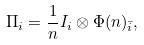<formula> <loc_0><loc_0><loc_500><loc_500>\Pi _ { i } = \frac { 1 } { n } I _ { i } \otimes \Phi ( n ) _ { \bar { i } } ,</formula> 